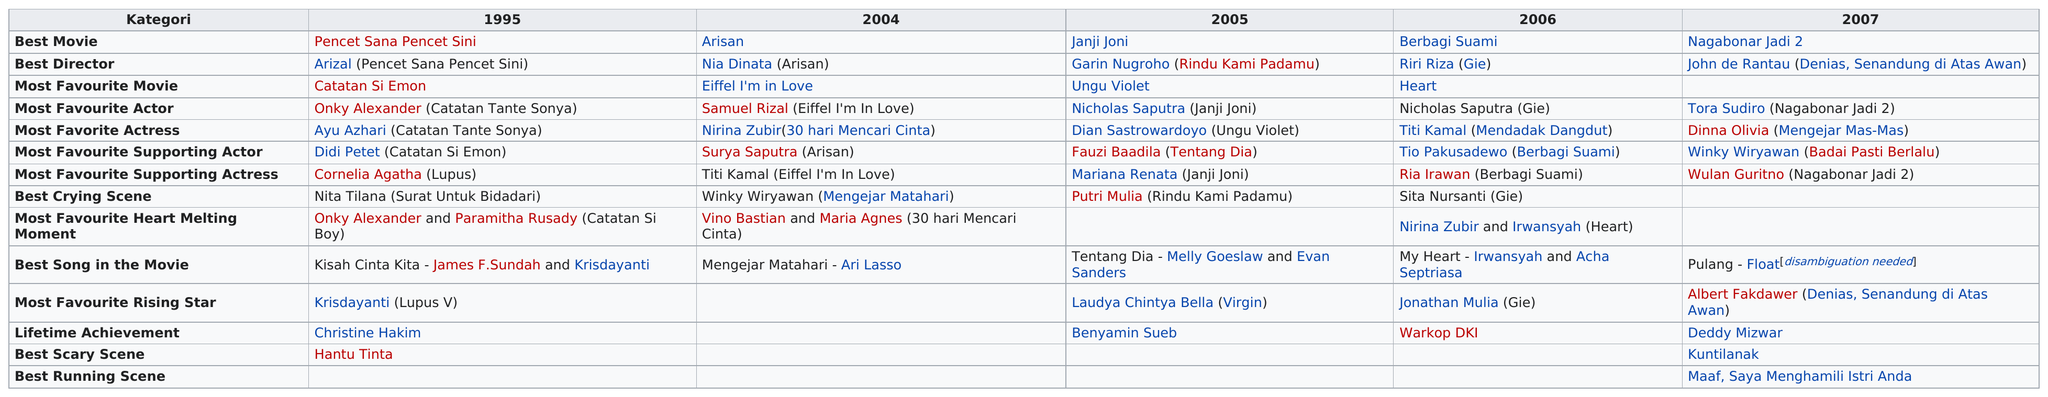Mention a couple of crucial points in this snapshot. Arisan won a total of three awards in 2004. Hantu Tinta and Kuntalanak both received the award for Best Scary Scene. In the year prior to Nicholas Saputra's favorite actor being Samuel Rizal. The person who won the award for Favorite Actress the year before Dian Sastrowardoyo won is Nirina Zubir. In 2004, 10 awards were given out. 